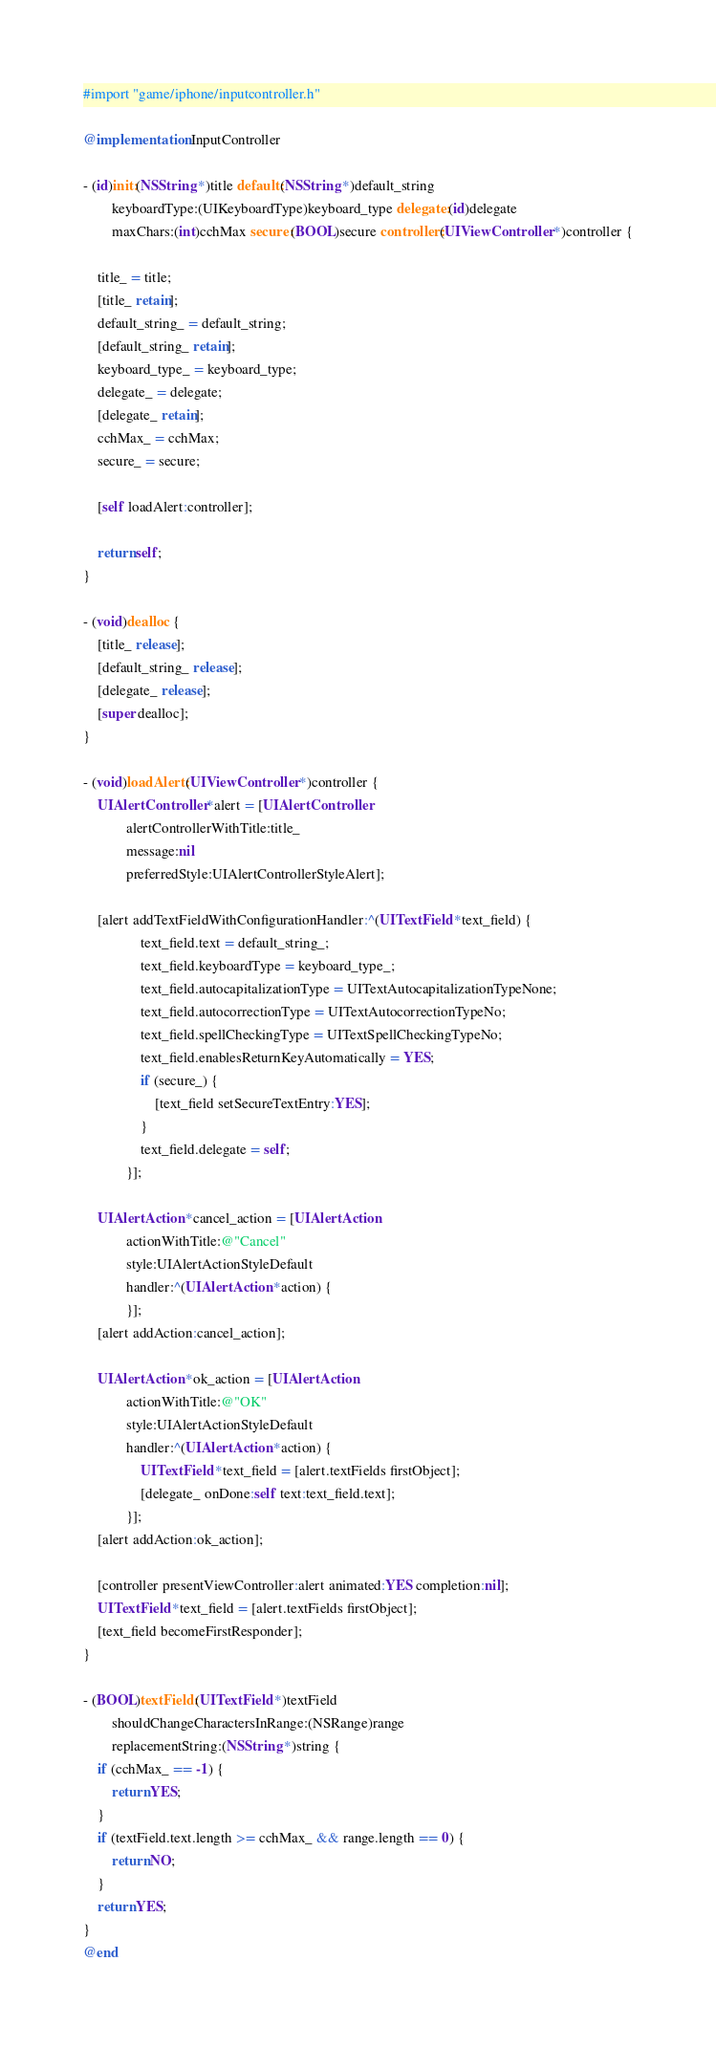<code> <loc_0><loc_0><loc_500><loc_500><_ObjectiveC_>#import "game/iphone/inputcontroller.h"

@implementation InputController

- (id)init:(NSString *)title default:(NSString *)default_string
        keyboardType:(UIKeyboardType)keyboard_type delegate:(id)delegate
        maxChars:(int)cchMax secure:(BOOL)secure controller:(UIViewController *)controller {

    title_ = title;
    [title_ retain]; 
    default_string_ = default_string;
    [default_string_ retain];
    keyboard_type_ = keyboard_type;
    delegate_ = delegate;
    [delegate_ retain];
    cchMax_ = cchMax;
    secure_ = secure;

    [self loadAlert:controller];

    return self;
}

- (void)dealloc {
    [title_ release];
    [default_string_ release];
    [delegate_ release];
    [super dealloc];
} 

- (void)loadAlert:(UIViewController *)controller {
    UIAlertController *alert = [UIAlertController
            alertControllerWithTitle:title_
            message:nil
            preferredStyle:UIAlertControllerStyleAlert];

    [alert addTextFieldWithConfigurationHandler:^(UITextField *text_field) {
                text_field.text = default_string_;
                text_field.keyboardType = keyboard_type_;
                text_field.autocapitalizationType = UITextAutocapitalizationTypeNone;
                text_field.autocorrectionType = UITextAutocorrectionTypeNo;
                text_field.spellCheckingType = UITextSpellCheckingTypeNo;
                text_field.enablesReturnKeyAutomatically = YES;
                if (secure_) {
                    [text_field setSecureTextEntry:YES];
                }
                text_field.delegate = self;
            }];

    UIAlertAction *cancel_action = [UIAlertAction
            actionWithTitle:@"Cancel"
            style:UIAlertActionStyleDefault
            handler:^(UIAlertAction *action) {
            }];
    [alert addAction:cancel_action];

    UIAlertAction *ok_action = [UIAlertAction
            actionWithTitle:@"OK"
            style:UIAlertActionStyleDefault
            handler:^(UIAlertAction *action) {
                UITextField *text_field = [alert.textFields firstObject];
                [delegate_ onDone:self text:text_field.text];
            }];
    [alert addAction:ok_action];

    [controller presentViewController:alert animated:YES completion:nil];
    UITextField *text_field = [alert.textFields firstObject];
    [text_field becomeFirstResponder];
}

- (BOOL)textField:(UITextField *)textField
        shouldChangeCharactersInRange:(NSRange)range
        replacementString:(NSString *)string {
    if (cchMax_ == -1) {
        return YES;
    }
    if (textField.text.length >= cchMax_ && range.length == 0) {
        return NO;
    }
    return YES;
}
@end
</code> 